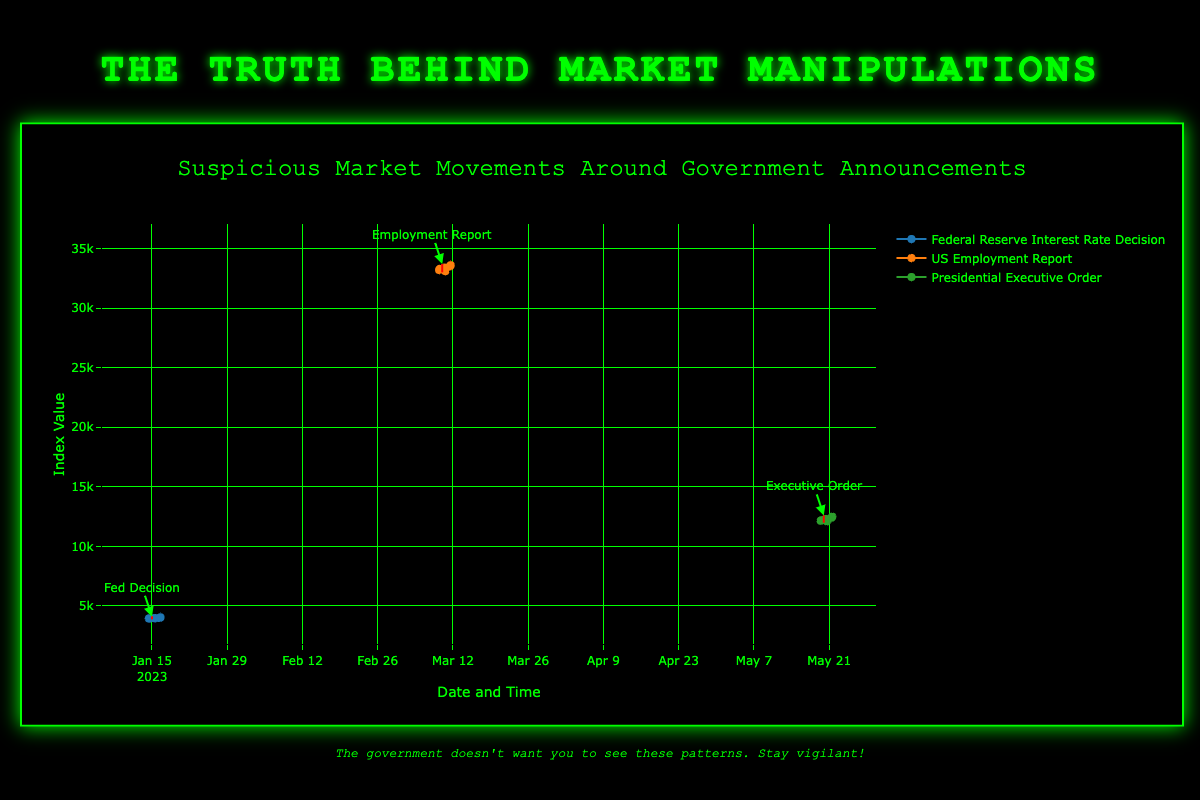What significant patterns can be observed in the S&P 500 Index around the Federal Reserve Interest Rate Decision on January 15, 2023? The S&P 500 Index shows a rise before the decision from 3950 to 3980, followed by a slight drop to 3970 after the decision and then a sharp increase to 4050 the day after. This suggests anticipation of the decision was met with initial fluctuation but eventually led to a positive market reaction.
Answer: Initial rise, slight drop, sharp increase How does the Dow Jones Industrial Average react before and after the US Employment Report on March 10, 2023, compared to the S&P 500's reaction to the Fed Decision on January 15, 2023? The Dow Jones shows a rise before the report, falling immediately after, and then increasing again, whereas the S&P 500 experiences a rise before, a slight drop after, and then a significant increase. Both show initial positive anticipation, followed by a negative immediate reaction, and eventual recovery.
Answer: Similar patterns with recovery Is there a more drastic change in the Nasdaq Composite Index before or after the Presidential Executive Order on May 20, 2023? The Nasdaq Composite rises slightly before the order, drops sharply immediately after, and then shows a considerable increase the next day, indicating the largest immediate drop among the three events but also significant recovery.
Answer: More drastic change after What is the overall pattern in stock market indices across all three events? All three indices rise before the government announcements, experience a drop immediately after, and then generally show a recovery or increase. This pattern suggests market anticipation and immediate re-evaluation upon the announcement.
Answer: Rise before, drop after, recovery Comparing the immediate effects of the announcements, which event had the most negative impact on the respective index shortly after the announcement time? The Presidential Executive Order had the most negative immediate impact on the Nasdaq Composite, which dropped from 12300 to 12100.
Answer: Presidential Executive Order Which event showed the greatest positive impact on its stock market index the day after the announcement? The Federal Reserve Interest Rate Decision on January 15, 2023, showed the greatest positive impact, with the S&P 500 Index increasing from 3980 to 4050.
Answer: Federal Reserve Interest Rate Decision What is the combined change in the S&P 500 Index from January 14, 2023, at 10:00 to January 16, 2023, at 14:00? The S&P 500 Index starts at 3950 and ends at 4050 during these dates, showing a combined increase of 100 points.
Answer: 100 points Considering the provided data points, which event had the least fluctuation from its initial to final data point? The US Employment Report had the least fluctuation in the Dow Jones Industrial Average, with a total range of 400 points (from 33200 to 33600).
Answer: US Employment Report How does the Dow Jones Industrial Average's movement on March 10, 2023, at 14:00 relate to its value on March 11, 2023, at 14:00? The index drops to 33100 on March 10, 2023, at 14:00 but rises to 33600 on March 11, 2023, at 14:00, indicating a recovery and surpassing the initial drop.
Answer: Recovery and increase What are the visual indicators that highlight significant events on the plot? Red dashed lines and corresponding annotations indicate significant events, providing clear visual markers for each government announcement.
Answer: Red dashed lines and annotations 